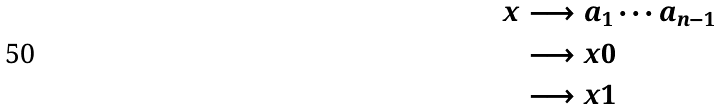Convert formula to latex. <formula><loc_0><loc_0><loc_500><loc_500>x & \longrightarrow a _ { 1 } \cdots a _ { n - 1 } \\ & \longrightarrow x 0 \\ & \longrightarrow x 1</formula> 